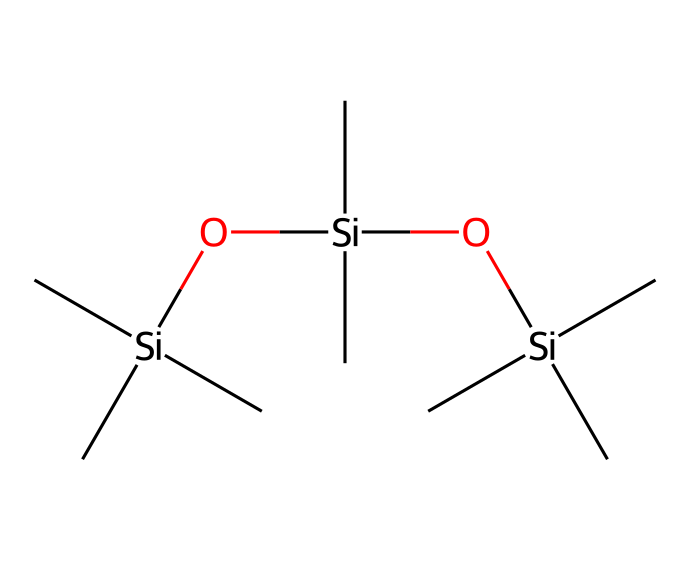how many silicon atoms are present in this compound? The given SMILES notation shows three instances of '[Si]', indicating that there are three silicon atoms in the structure.
Answer: three what type of chemical compound is represented by this structure? The presence of silicon atoms bonded to carbon and oxygen suggests that this compound is an organosilicon compound, characterized by its silicon-carbon bonds.
Answer: organosilicon how many carbon atoms are in the structure? Analyzing the SMILES notation, there are nine 'C' notations (each represents a carbon atom), thus there are nine carbon atoms present in this structure.
Answer: nine what is the role of the oxygen atoms in this compound? The oxygen atoms (two instances of 'O') typically function to provide hydrophilicity, but in this context, they enhance the water-repellent property of the spray by linking silicone groups together.
Answer: water-repellent what type of bonding is primarily present between silicon and carbon in this compound? The bonds between the silicon atoms and carbon atoms are predominantly covalent bonds, as evidenced by the connectivity in the SMILES representation.
Answer: covalent how might the structure contribute to water repellency? The arrangement of silicon and carbon atoms, along with the presence of oxygen, creates a hydrophobic surface that repels water effectively, which is essential for protecting books during outdoor events.
Answer: hydrophobic surface do the functional groups in this compound suggest any specific application? The structure indicates silanol (Si-OH) functionality, which is significant for creating coatings that repel water, thus making it suitable for use in water-repellent sprays.
Answer: water-repellent sprays 